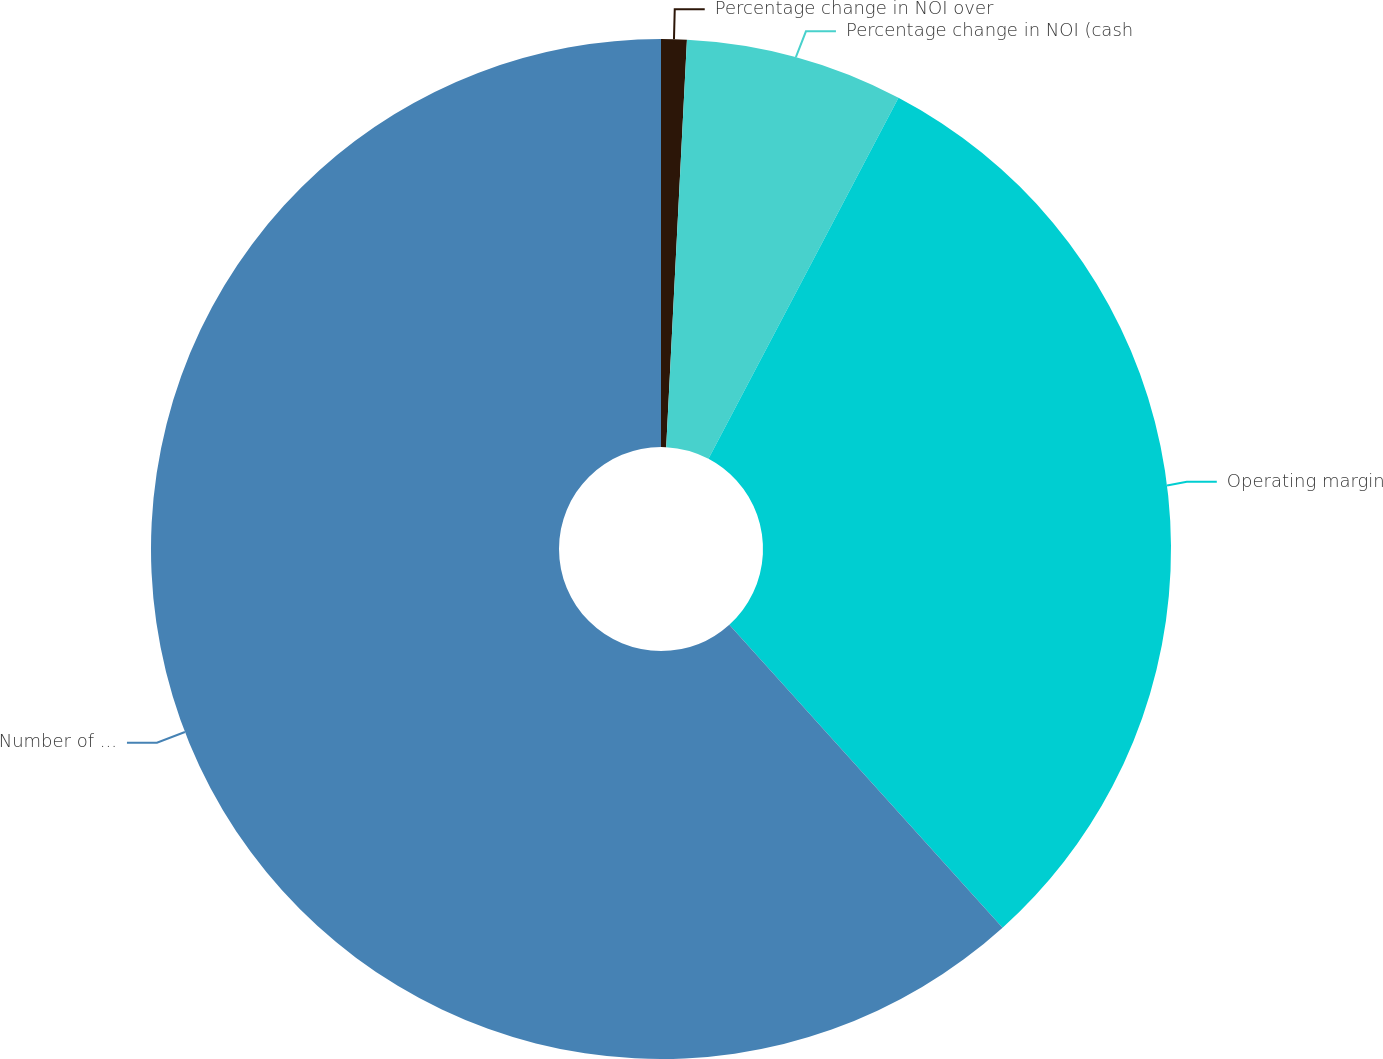<chart> <loc_0><loc_0><loc_500><loc_500><pie_chart><fcel>Percentage change in NOI over<fcel>Percentage change in NOI (cash<fcel>Operating margin<fcel>Number of Same Properties<nl><fcel>0.81%<fcel>6.9%<fcel>30.61%<fcel>61.68%<nl></chart> 